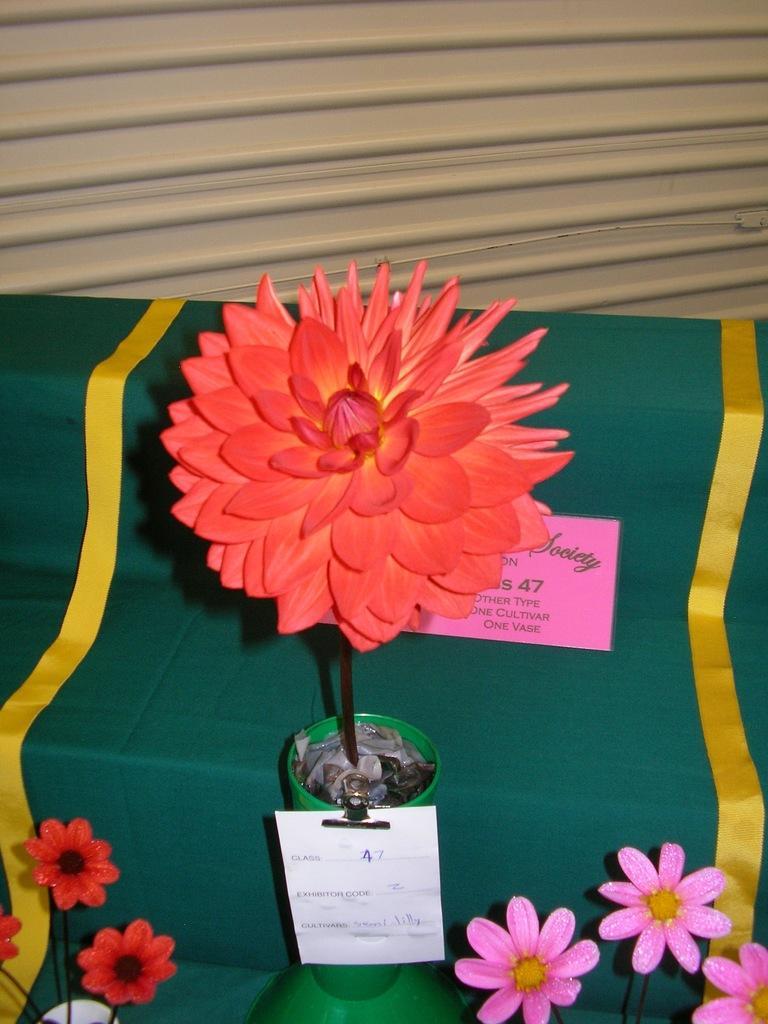Please provide a concise description of this image. In this image there is a table, on that table there is a cloth on that there are flower vases, in the background there is a shutter. 